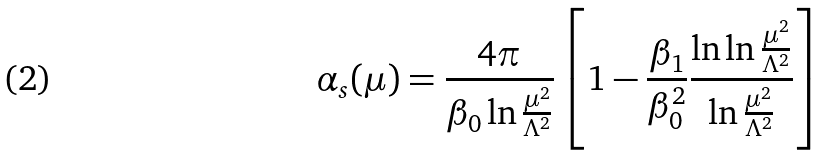<formula> <loc_0><loc_0><loc_500><loc_500>\alpha _ { s } ( \mu ) = \frac { 4 \pi } { \beta _ { 0 } \ln \frac { \mu ^ { 2 } } { \Lambda ^ { 2 } } } \left [ 1 - \frac { \beta _ { 1 } } { \beta _ { 0 } ^ { 2 } } \frac { \ln \ln \frac { \mu ^ { 2 } } { \Lambda ^ { 2 } } } { \ln \frac { \mu ^ { 2 } } { \Lambda ^ { 2 } } } \right ]</formula> 